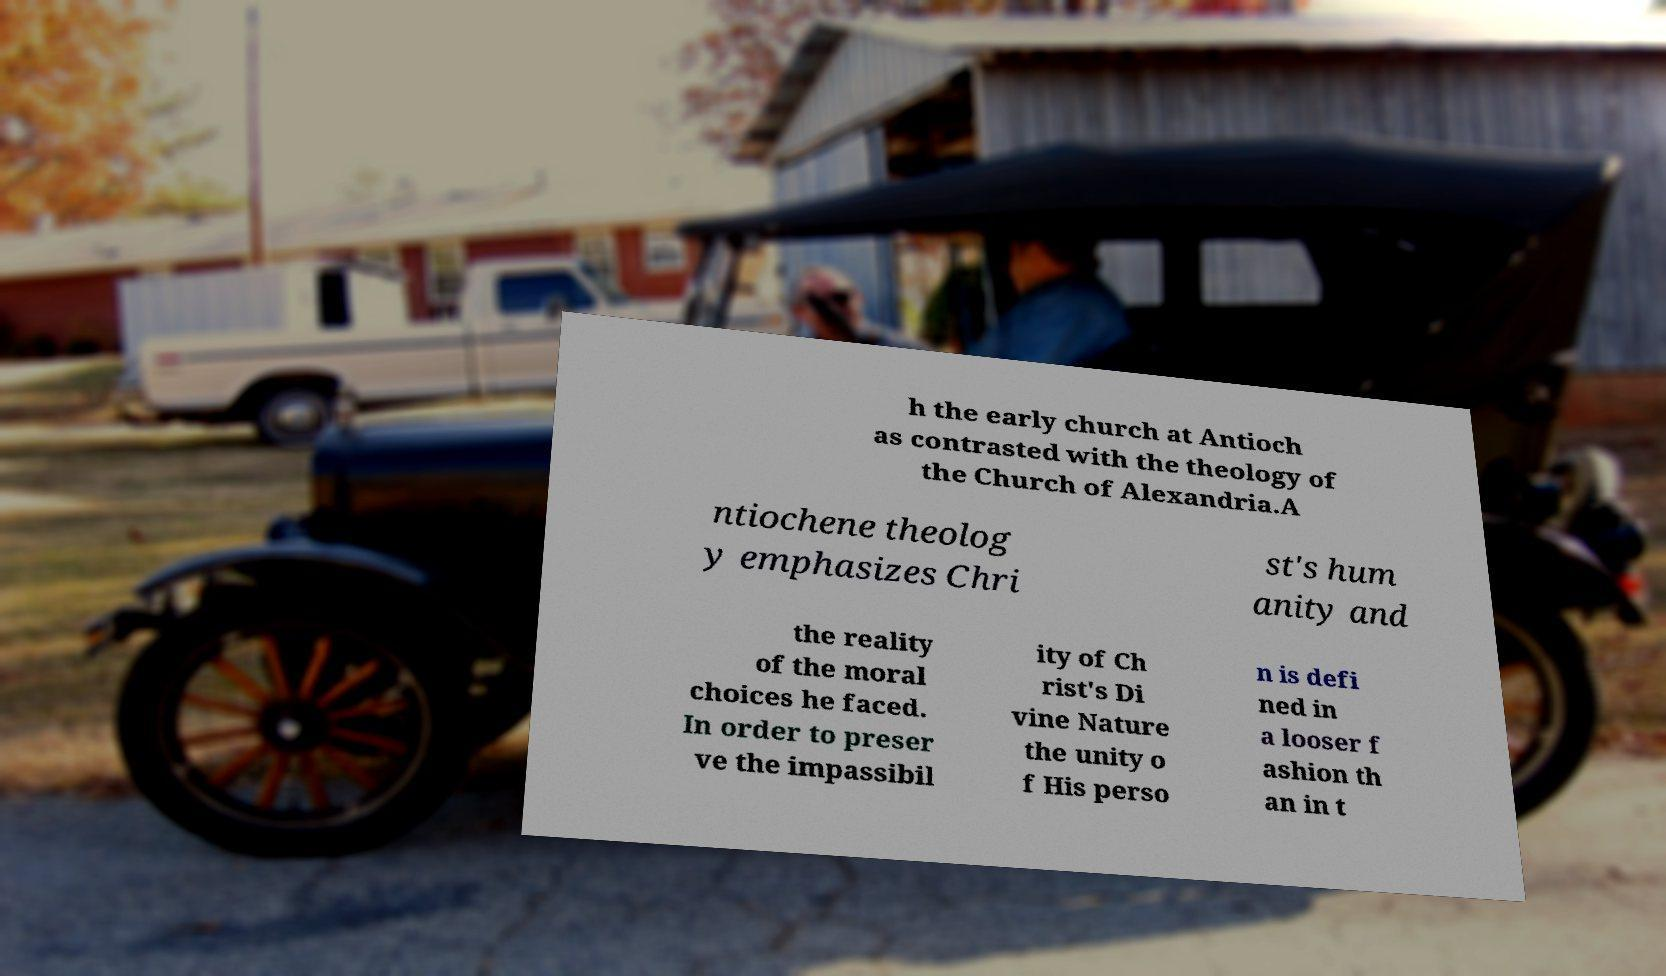Can you accurately transcribe the text from the provided image for me? h the early church at Antioch as contrasted with the theology of the Church of Alexandria.A ntiochene theolog y emphasizes Chri st's hum anity and the reality of the moral choices he faced. In order to preser ve the impassibil ity of Ch rist's Di vine Nature the unity o f His perso n is defi ned in a looser f ashion th an in t 